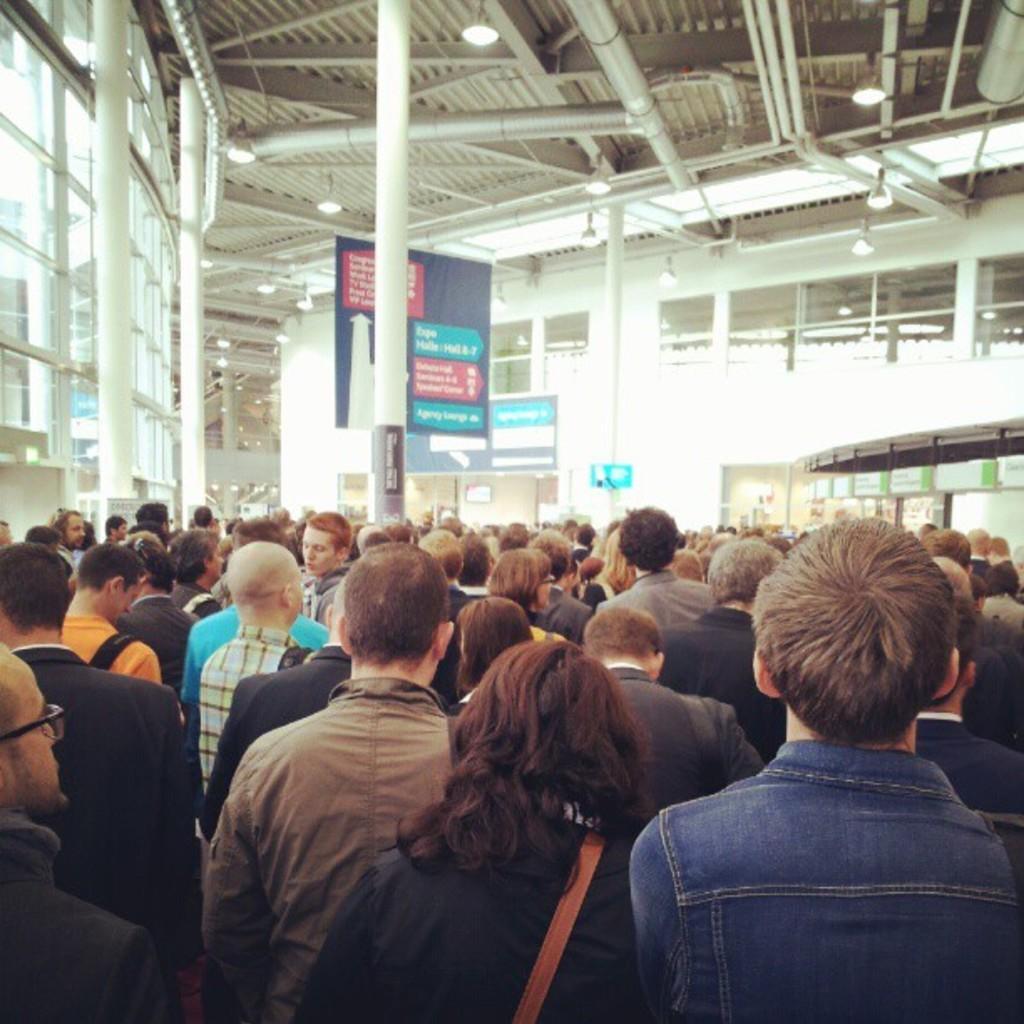Could you give a brief overview of what you see in this image? In this image we can see a group of people standing. One person is wearing spectacles. In the center of the image we can see group of poles, banner with some text. In the background, we can see lights, staircase and some screens. 